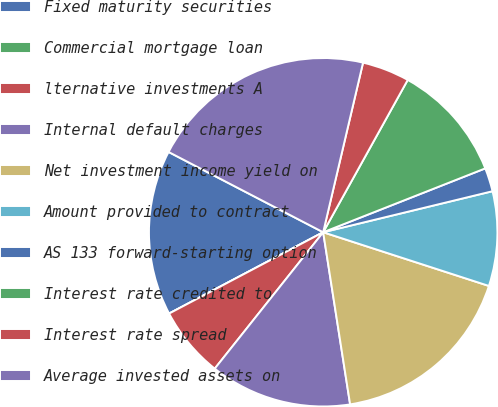Convert chart. <chart><loc_0><loc_0><loc_500><loc_500><pie_chart><fcel>Fixed maturity securities<fcel>Commercial mortgage loan<fcel>lternative investments A<fcel>Internal default charges<fcel>Net investment income yield on<fcel>Amount provided to contract<fcel>AS 133 forward-starting option<fcel>Interest rate credited to<fcel>Interest rate spread<fcel>Average invested assets on<nl><fcel>15.35%<fcel>0.0%<fcel>6.58%<fcel>13.16%<fcel>17.54%<fcel>8.77%<fcel>2.19%<fcel>10.96%<fcel>4.39%<fcel>21.05%<nl></chart> 